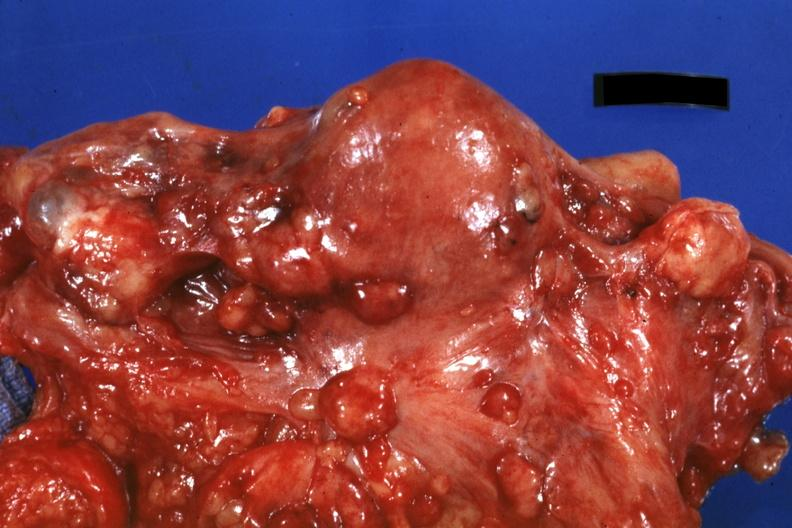where is this area in the body?
Answer the question using a single word or phrase. Abdomen 